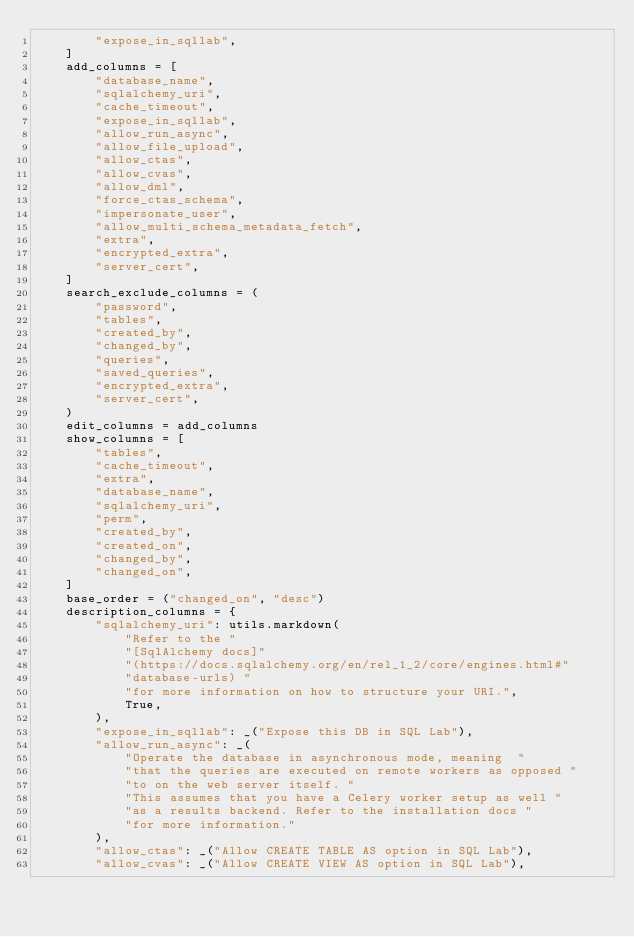Convert code to text. <code><loc_0><loc_0><loc_500><loc_500><_Python_>        "expose_in_sqllab",
    ]
    add_columns = [
        "database_name",
        "sqlalchemy_uri",
        "cache_timeout",
        "expose_in_sqllab",
        "allow_run_async",
        "allow_file_upload",
        "allow_ctas",
        "allow_cvas",
        "allow_dml",
        "force_ctas_schema",
        "impersonate_user",
        "allow_multi_schema_metadata_fetch",
        "extra",
        "encrypted_extra",
        "server_cert",
    ]
    search_exclude_columns = (
        "password",
        "tables",
        "created_by",
        "changed_by",
        "queries",
        "saved_queries",
        "encrypted_extra",
        "server_cert",
    )
    edit_columns = add_columns
    show_columns = [
        "tables",
        "cache_timeout",
        "extra",
        "database_name",
        "sqlalchemy_uri",
        "perm",
        "created_by",
        "created_on",
        "changed_by",
        "changed_on",
    ]
    base_order = ("changed_on", "desc")
    description_columns = {
        "sqlalchemy_uri": utils.markdown(
            "Refer to the "
            "[SqlAlchemy docs]"
            "(https://docs.sqlalchemy.org/en/rel_1_2/core/engines.html#"
            "database-urls) "
            "for more information on how to structure your URI.",
            True,
        ),
        "expose_in_sqllab": _("Expose this DB in SQL Lab"),
        "allow_run_async": _(
            "Operate the database in asynchronous mode, meaning  "
            "that the queries are executed on remote workers as opposed "
            "to on the web server itself. "
            "This assumes that you have a Celery worker setup as well "
            "as a results backend. Refer to the installation docs "
            "for more information."
        ),
        "allow_ctas": _("Allow CREATE TABLE AS option in SQL Lab"),
        "allow_cvas": _("Allow CREATE VIEW AS option in SQL Lab"),</code> 